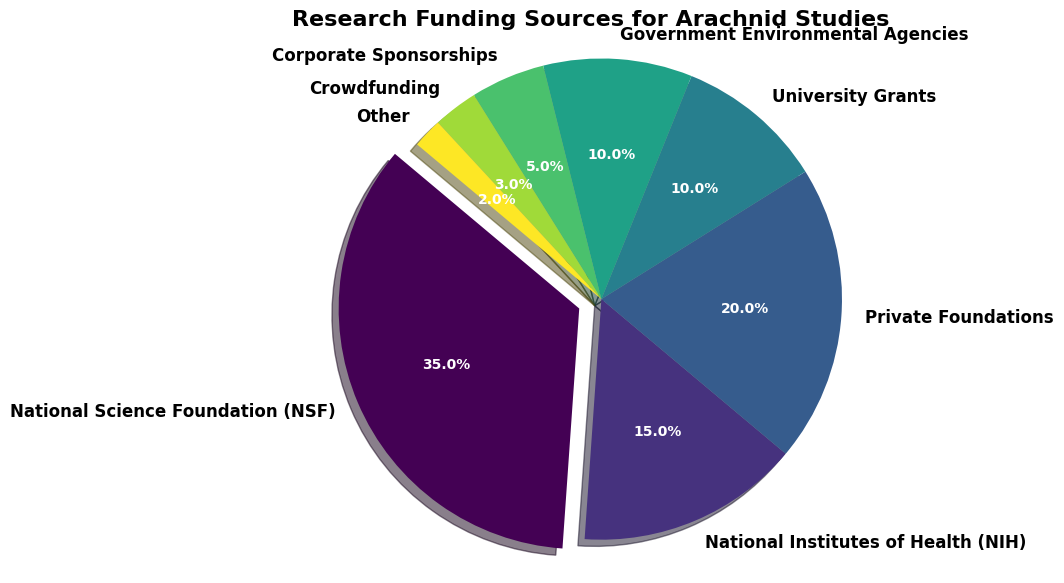What percentage of the total research funding comes from government sources? The total research funding percentage from government sources is the sum of contributions from the National Science Foundation (35%), National Institutes of Health (15%), and Government Environmental Agencies (10%). Adding these up, 35 + 15 + 10 = 60%.
Answer: 60% Which funding source contributes the least to arachnid studies? By examining the percentages in the pie chart, the smallest slice corresponds to "Other" with 2%.
Answer: Other What is the difference in funding percentage between Private Foundations and University Grants? Private Foundations contribute 20% and University Grants contribute 10%. The difference is calculated by subtracting the smaller percentage from the larger one: 20 - 10 = 10%.
Answer: 10% How does the percentage of funding from Crowdfunding compare to Corporate Sponsorships? Crowdfunding contributes 3% while Corporate Sponsorships contribute 5%. Comparatively, Corporate Sponsorships provide a higher percentage of funding.
Answer: Corporate Sponsorships What is the combined contribution of Private Foundations and Corporate Sponsorships? To find the combined contribution, add the percentages from Private Foundations (20%) and Corporate Sponsorships (5%): 20 + 5 = 25%.
Answer: 25% Which funding source is highlighted (exploded) in the pie chart? The National Science Foundation (NSF) is highlighted because it has the highest percentage (35%), and the largest wedge is exploded.
Answer: National Science Foundation (NSF) If we combine the funding percentages of University Grants and Government Environmental Agencies, does it match the percentage provided by the National Institutes of Health (NIH)? Combining University Grants (10%) and Government Environmental Agencies (10%) gives 10 + 10 = 20%, which is higher than the 15% from the NIH.
Answer: No What is the visual feature used to make the National Science Foundation (NSF) wedge stand out? The NSF wedge is exploded outwards from the center of the pie chart, making it visually distinct from the others.
Answer: Exploded Which two funding sources together make up nearly half of the total funding? The National Science Foundation (35%) and Private Foundations (20%) together contribute 35 + 20 = 55%, which is more than half. To get a combination closest to half, consider the National Science Foundation (35%) and National Institutes of Health (15%) together, which make up 35 + 15 = 50%.
Answer: National Science Foundation and National Institutes of Health 